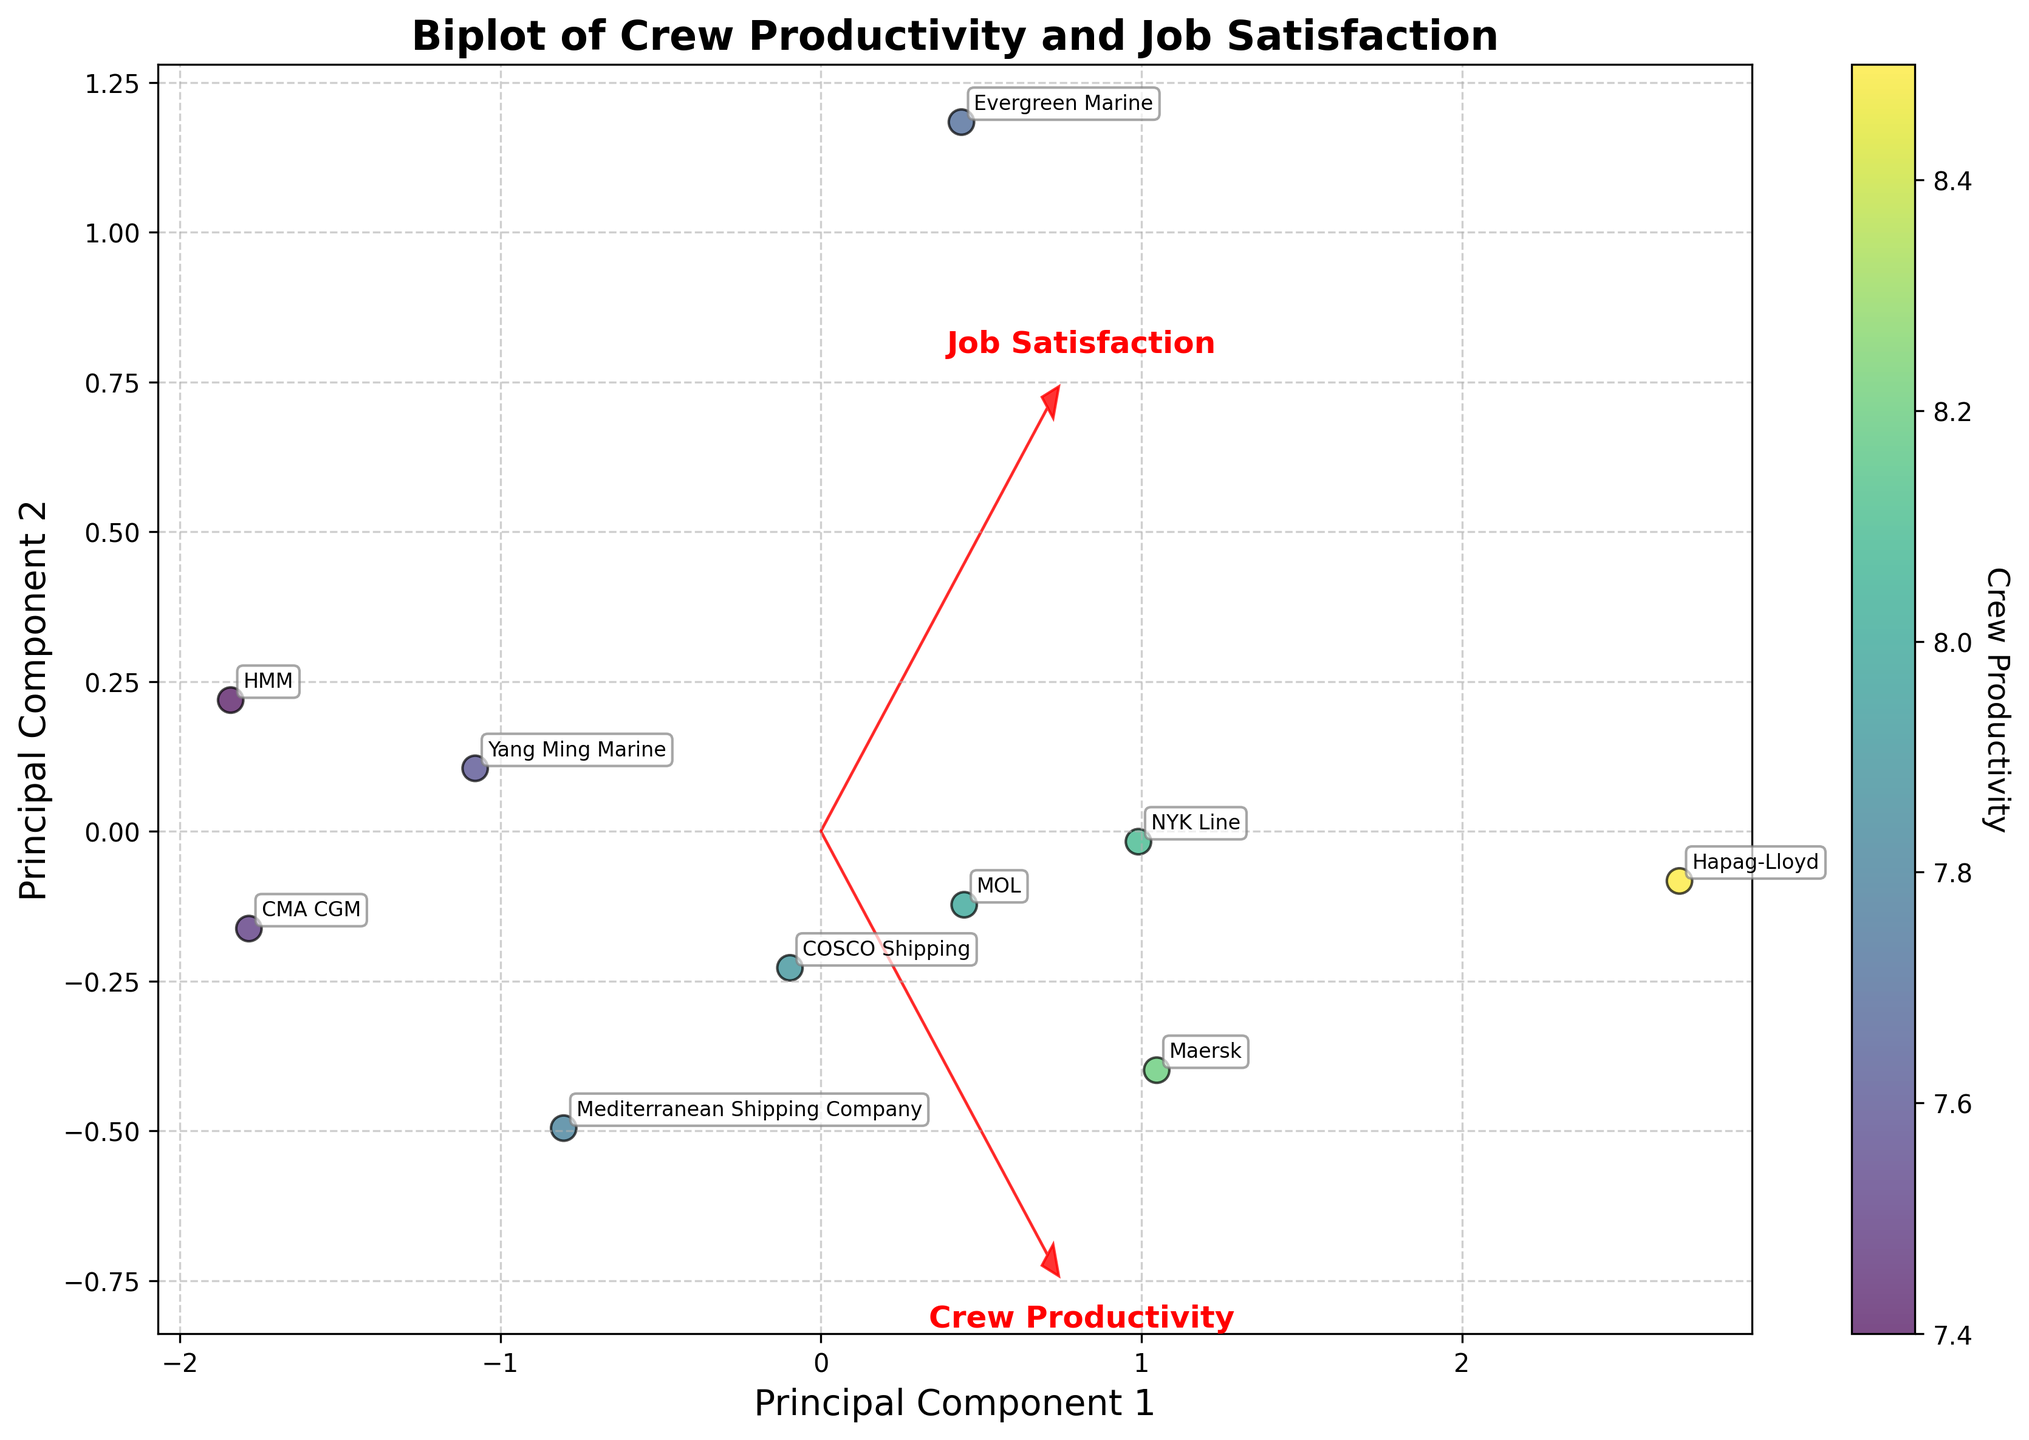How many shipping companies are represented in the plot? The plot annotates each data point with the name of the shipping company. By counting these annotations, we can determine the number of distinct companies.
Answer: 10 Which company has the highest crew productivity on the plot? By examining the color gradient of the scatter points, which represents crew productivity, the data point with the darkest color corresponds to the highest productivity value.
Answer: Hapag-Lloyd Which vessel type is associated with a company that has above-average job satisfaction? To identify this, cross-check vessel types with the job satisfaction axis. Points above the middle value (around 7) on the Job Satisfaction axis will indicate above average job satisfaction.
Answer: LNG Carrier Is there any company with low crew productivity but high job satisfaction? Look for a data point with a lighter color (indicating lower productivity) and a higher position on the y-axis (indicating higher job satisfaction).
Answer: Evergreen Marine What's the range of crew productivity across all companies? First, identify the data points with the maximum and minimum color intensity on the scatter plot, which indicates the highest and lowest crew productivity. Calculate the range by subtracting the lowest productivity value from the highest.
Answer: 7.4 to 8.5 Which two companies have the most similar crew productivity and job satisfaction levels? Examine the coordinates of the points and find two points that are the closest to each other.
Answer: Maersk and NYK Line Which principal component primarily explains job satisfaction? Examine the direction and label of the red arrow representing "Job Satisfaction" to see which principal component it aligns with most.
Answer: Principal Component 2 Compare the crew productivity of Maersk and HMM. Which one is higher? Locate the data points for Maersk and HMM and compare their color intensities to determine which point has a darker shade.
Answer: Maersk How does Hapag-Lloyd's job satisfaction compare to that of CMA CGM? Locate the points for Hapag-Lloyd and CMA CGM and compare their positions on the y-axis. The point higher on the y-axis has higher job satisfaction.
Answer: Higher Which company lies closest to the origin of the principal components? Identify the data point closest to (0, 0) on the plot. This represents the company nearest to the origin in terms of both principal components.
Answer: Yang Ming Marine 